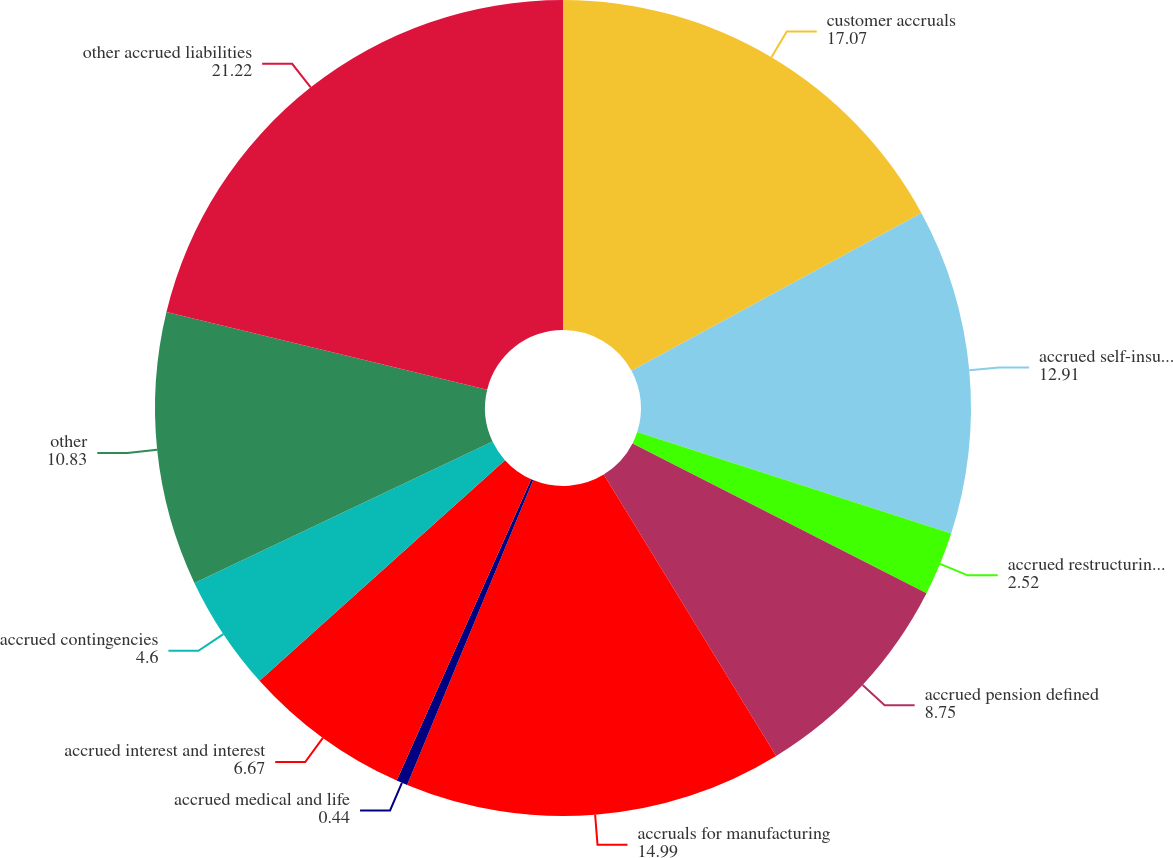<chart> <loc_0><loc_0><loc_500><loc_500><pie_chart><fcel>customer accruals<fcel>accrued self-insurance<fcel>accrued restructuring (See<fcel>accrued pension defined<fcel>accruals for manufacturing<fcel>accrued medical and life<fcel>accrued interest and interest<fcel>accrued contingencies<fcel>other<fcel>other accrued liabilities<nl><fcel>17.07%<fcel>12.91%<fcel>2.52%<fcel>8.75%<fcel>14.99%<fcel>0.44%<fcel>6.67%<fcel>4.6%<fcel>10.83%<fcel>21.22%<nl></chart> 